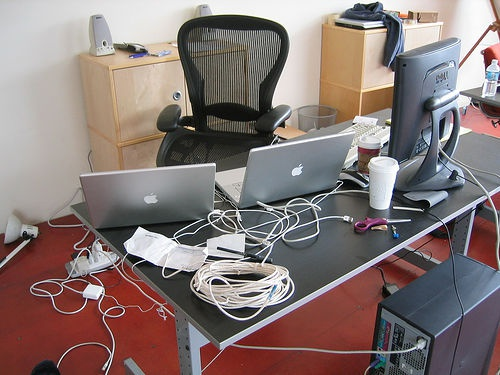Describe the objects in this image and their specific colors. I can see chair in lightgray, black, gray, and darkgray tones, tv in lightgray, gray, black, and darkgray tones, laptop in lightgray, gray, darkgray, and black tones, laptop in lightgray and gray tones, and cup in lightgray, darkgray, and gray tones in this image. 